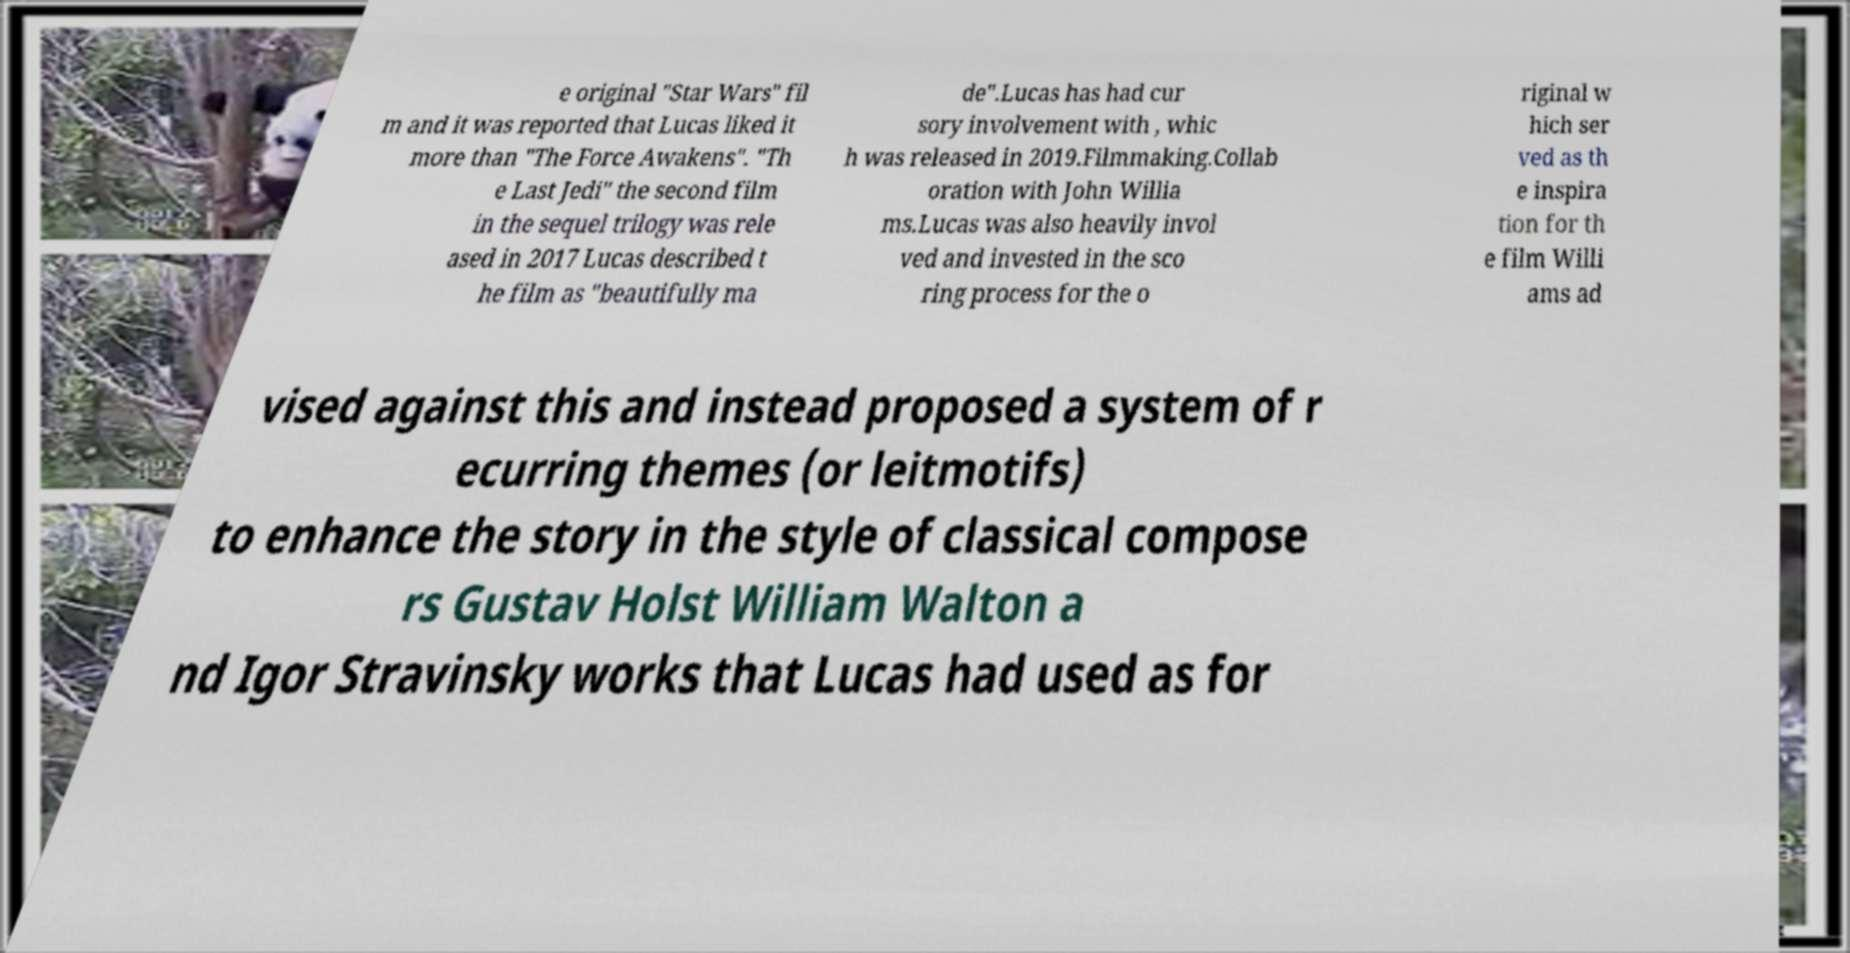What messages or text are displayed in this image? I need them in a readable, typed format. e original "Star Wars" fil m and it was reported that Lucas liked it more than "The Force Awakens". "Th e Last Jedi" the second film in the sequel trilogy was rele ased in 2017 Lucas described t he film as "beautifully ma de".Lucas has had cur sory involvement with , whic h was released in 2019.Filmmaking.Collab oration with John Willia ms.Lucas was also heavily invol ved and invested in the sco ring process for the o riginal w hich ser ved as th e inspira tion for th e film Willi ams ad vised against this and instead proposed a system of r ecurring themes (or leitmotifs) to enhance the story in the style of classical compose rs Gustav Holst William Walton a nd Igor Stravinsky works that Lucas had used as for 